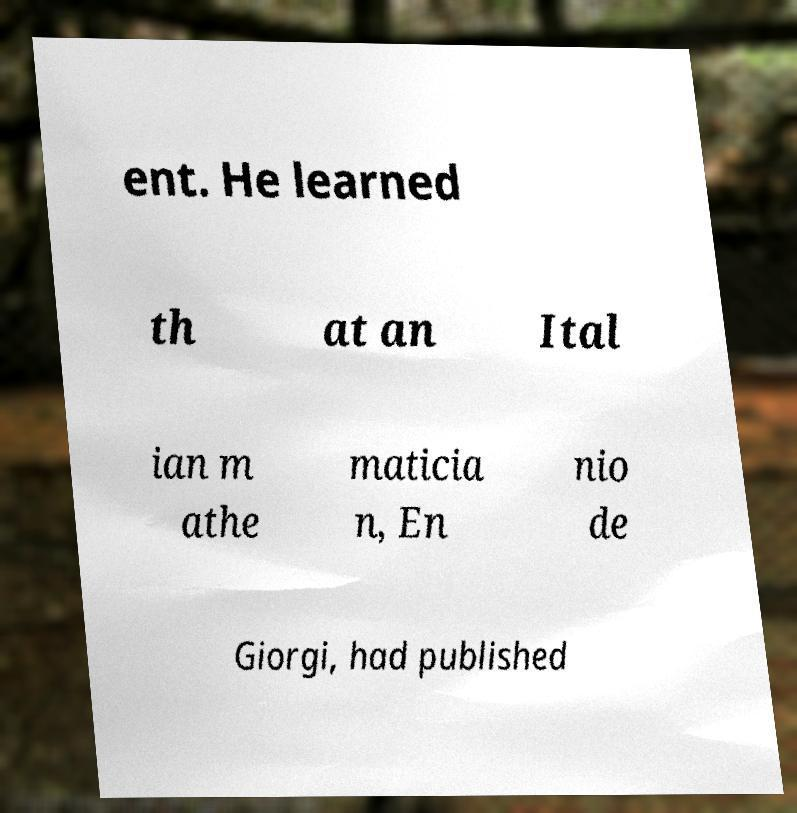Please identify and transcribe the text found in this image. ent. He learned th at an Ital ian m athe maticia n, En nio de Giorgi, had published 